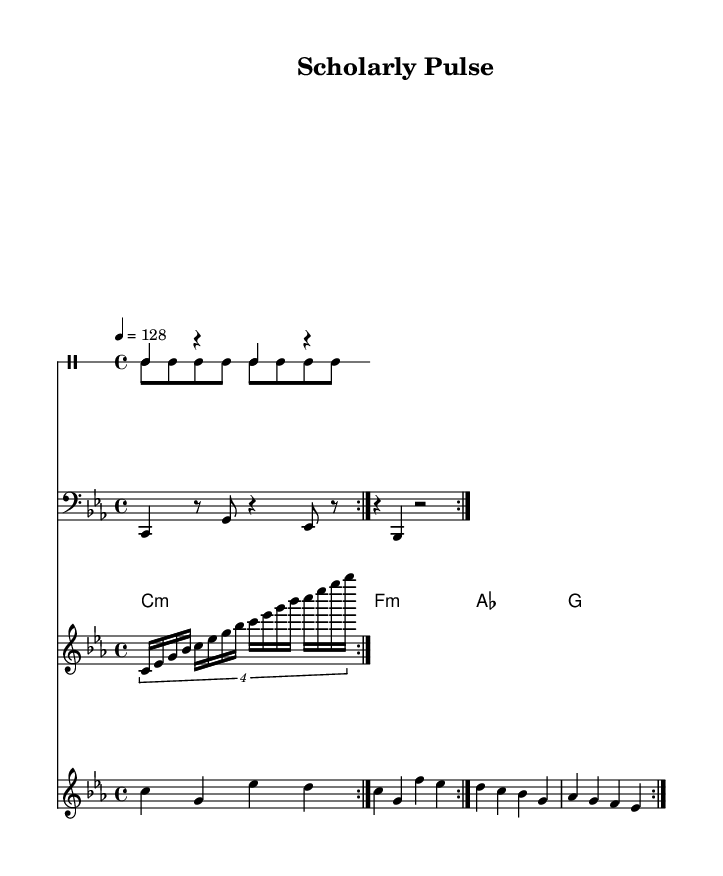What is the key signature of this music? The key signature is C minor, which has three flats: B flat, E flat, and A flat.
Answer: C minor What is the time signature of this piece? The time signature is indicated as 4/4, meaning there are four beats in each measure and the quarter note gets one beat.
Answer: 4/4 What is the tempo marked in the sheet music? The tempo is marked as quarter note equals 128 beats per minute, indicating a moderately fast pace suitable for minimal techno.
Answer: 128 How many times is the kick drum pattern repeated? The kick drum pattern is repeated twice as indicated by the volta marking in the drum part.
Answer: 2 What type of chords are used in the pad chords section? The pad chords section consists of minor and major chords, specifically C minor, F minor, A flat major, and G major.
Answer: Minor and major What instruments are notated in the score? The score includes a kick drum, hi-hat, synth bass, arpeggiator, and lead synth, showing a typical electronic music setup.
Answer: Kick drum, hi-hat, synth bass, arpeggiator, lead synth How does the arpeggiator function in this piece? The arpeggiator plays a sequence of notes across octaves in a rapid succession, creating a flowing texture typical in minimal techno music.
Answer: Rapid succession 